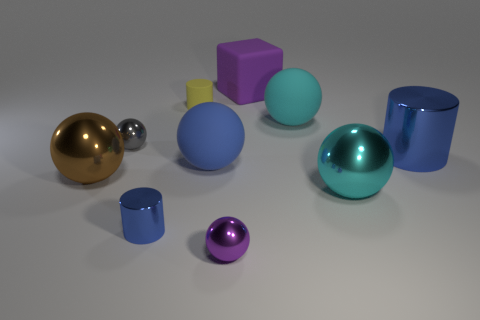There is a small matte object; does it have the same color as the tiny shiny sphere that is to the right of the tiny gray sphere?
Your response must be concise. No. How many things are shiny objects that are on the left side of the matte block or blue shiny cylinders left of the small purple thing?
Your answer should be compact. 4. What is the shape of the tiny metal thing that is behind the blue shiny cylinder behind the cyan shiny object?
Ensure brevity in your answer.  Sphere. Is there a purple block that has the same material as the small gray sphere?
Make the answer very short. No. What is the color of the other metal thing that is the same shape as the big blue shiny object?
Your response must be concise. Blue. Are there fewer large cyan shiny things that are in front of the tiny blue cylinder than large cyan matte things that are on the left side of the purple sphere?
Ensure brevity in your answer.  No. How many other things are there of the same shape as the brown metal object?
Offer a terse response. 5. Is the number of small objects that are right of the big brown object less than the number of large cyan rubber things?
Make the answer very short. No. What material is the cube behind the small gray shiny ball?
Provide a succinct answer. Rubber. What number of other things are there of the same size as the cyan metal sphere?
Your response must be concise. 5. 